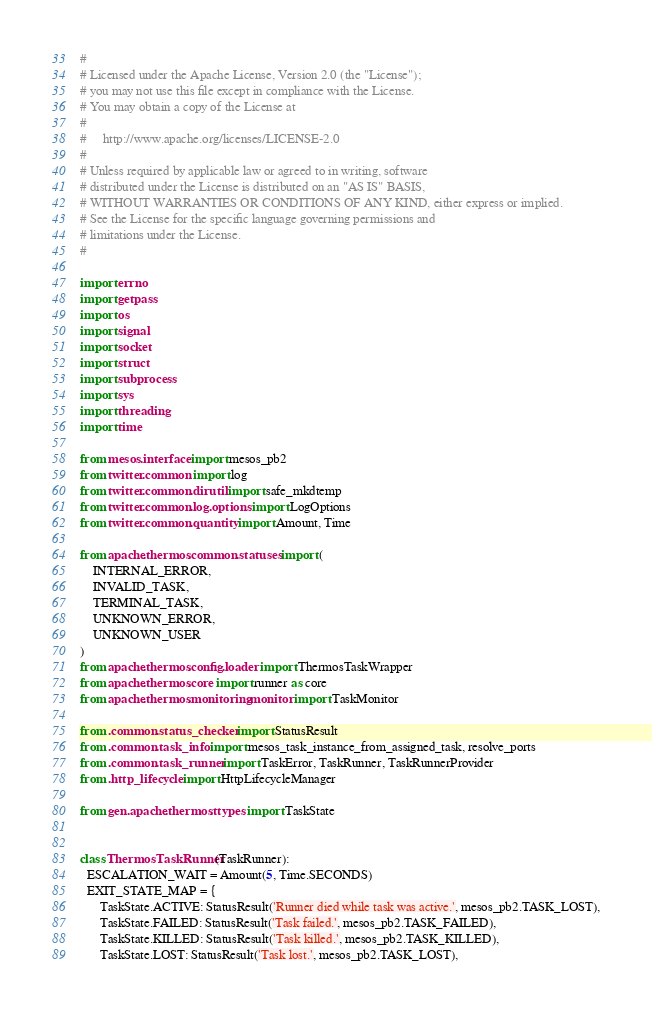Convert code to text. <code><loc_0><loc_0><loc_500><loc_500><_Python_>#
# Licensed under the Apache License, Version 2.0 (the "License");
# you may not use this file except in compliance with the License.
# You may obtain a copy of the License at
#
#     http://www.apache.org/licenses/LICENSE-2.0
#
# Unless required by applicable law or agreed to in writing, software
# distributed under the License is distributed on an "AS IS" BASIS,
# WITHOUT WARRANTIES OR CONDITIONS OF ANY KIND, either express or implied.
# See the License for the specific language governing permissions and
# limitations under the License.
#

import errno
import getpass
import os
import signal
import socket
import struct
import subprocess
import sys
import threading
import time

from mesos.interface import mesos_pb2
from twitter.common import log
from twitter.common.dirutil import safe_mkdtemp
from twitter.common.log.options import LogOptions
from twitter.common.quantity import Amount, Time

from apache.thermos.common.statuses import (
    INTERNAL_ERROR,
    INVALID_TASK,
    TERMINAL_TASK,
    UNKNOWN_ERROR,
    UNKNOWN_USER
)
from apache.thermos.config.loader import ThermosTaskWrapper
from apache.thermos.core import runner as core
from apache.thermos.monitoring.monitor import TaskMonitor

from .common.status_checker import StatusResult
from .common.task_info import mesos_task_instance_from_assigned_task, resolve_ports
from .common.task_runner import TaskError, TaskRunner, TaskRunnerProvider
from .http_lifecycle import HttpLifecycleManager

from gen.apache.thermos.ttypes import TaskState


class ThermosTaskRunner(TaskRunner):
  ESCALATION_WAIT = Amount(5, Time.SECONDS)
  EXIT_STATE_MAP = {
      TaskState.ACTIVE: StatusResult('Runner died while task was active.', mesos_pb2.TASK_LOST),
      TaskState.FAILED: StatusResult('Task failed.', mesos_pb2.TASK_FAILED),
      TaskState.KILLED: StatusResult('Task killed.', mesos_pb2.TASK_KILLED),
      TaskState.LOST: StatusResult('Task lost.', mesos_pb2.TASK_LOST),</code> 